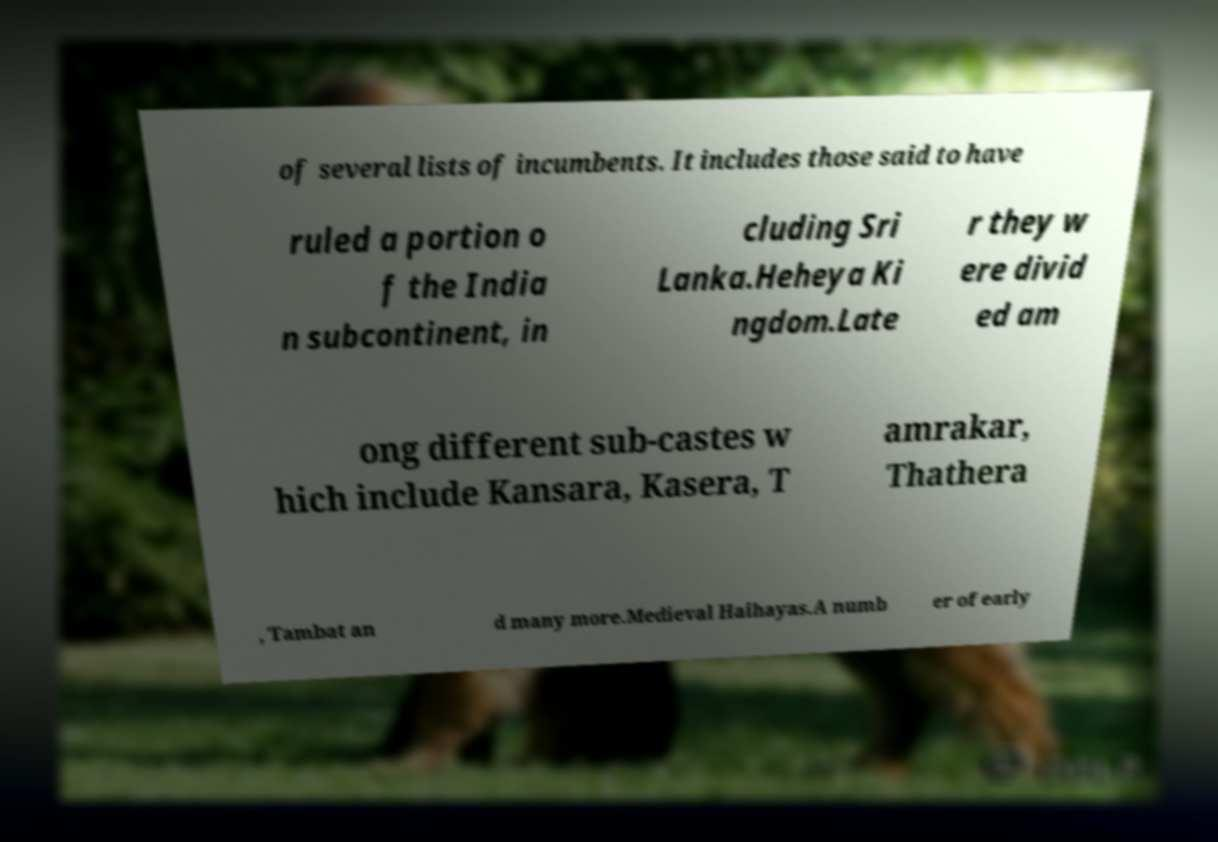What messages or text are displayed in this image? I need them in a readable, typed format. of several lists of incumbents. It includes those said to have ruled a portion o f the India n subcontinent, in cluding Sri Lanka.Heheya Ki ngdom.Late r they w ere divid ed am ong different sub-castes w hich include Kansara, Kasera, T amrakar, Thathera , Tambat an d many more.Medieval Haihayas.A numb er of early 